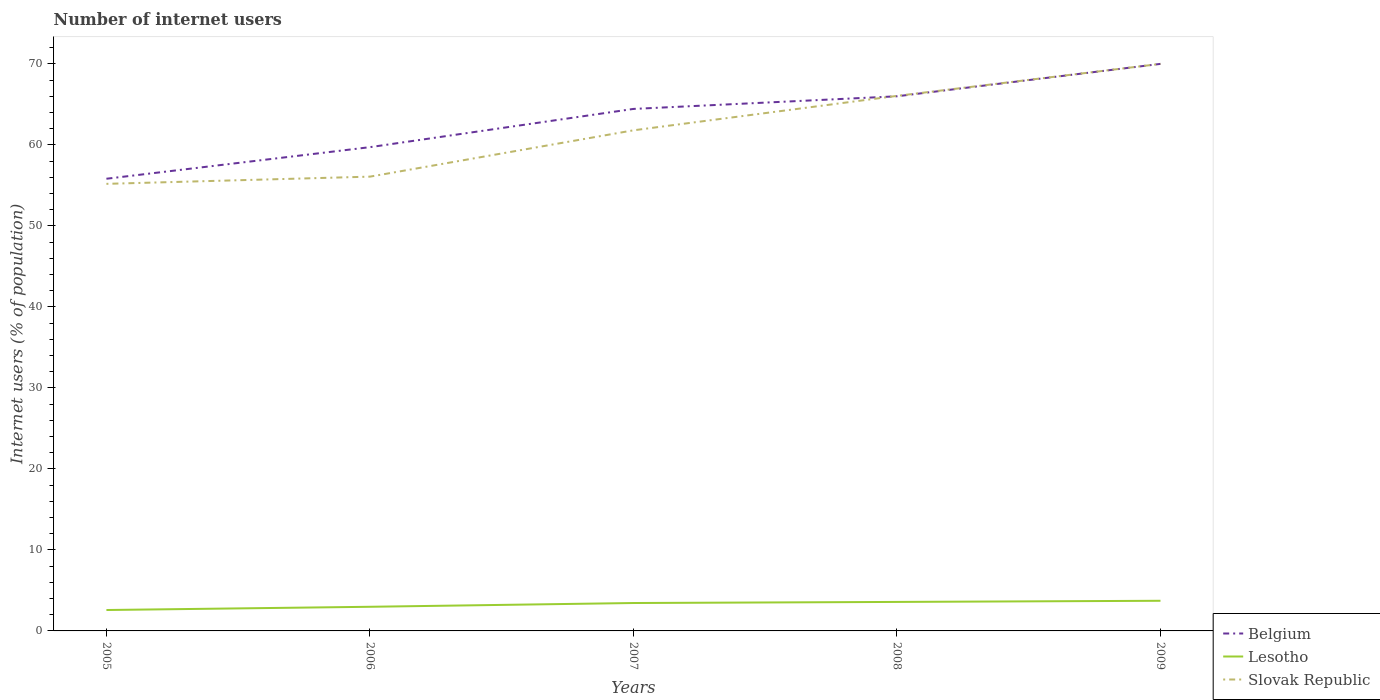How many different coloured lines are there?
Provide a succinct answer. 3. Does the line corresponding to Slovak Republic intersect with the line corresponding to Lesotho?
Provide a short and direct response. No. Is the number of lines equal to the number of legend labels?
Offer a terse response. Yes. Across all years, what is the maximum number of internet users in Lesotho?
Keep it short and to the point. 2.58. In which year was the number of internet users in Slovak Republic maximum?
Make the answer very short. 2005. What is the total number of internet users in Lesotho in the graph?
Offer a terse response. -0.87. What is the difference between the highest and the second highest number of internet users in Slovak Republic?
Your answer should be very brief. 14.81. Is the number of internet users in Belgium strictly greater than the number of internet users in Lesotho over the years?
Your answer should be compact. No. How many legend labels are there?
Your response must be concise. 3. What is the title of the graph?
Offer a terse response. Number of internet users. Does "Burundi" appear as one of the legend labels in the graph?
Ensure brevity in your answer.  No. What is the label or title of the X-axis?
Offer a terse response. Years. What is the label or title of the Y-axis?
Your response must be concise. Internet users (% of population). What is the Internet users (% of population) in Belgium in 2005?
Offer a terse response. 55.82. What is the Internet users (% of population) in Lesotho in 2005?
Your answer should be compact. 2.58. What is the Internet users (% of population) of Slovak Republic in 2005?
Give a very brief answer. 55.19. What is the Internet users (% of population) in Belgium in 2006?
Make the answer very short. 59.72. What is the Internet users (% of population) of Lesotho in 2006?
Your answer should be compact. 2.98. What is the Internet users (% of population) in Slovak Republic in 2006?
Make the answer very short. 56.08. What is the Internet users (% of population) of Belgium in 2007?
Provide a short and direct response. 64.44. What is the Internet users (% of population) in Lesotho in 2007?
Your response must be concise. 3.45. What is the Internet users (% of population) in Slovak Republic in 2007?
Provide a short and direct response. 61.8. What is the Internet users (% of population) of Belgium in 2008?
Give a very brief answer. 66. What is the Internet users (% of population) in Lesotho in 2008?
Provide a succinct answer. 3.58. What is the Internet users (% of population) of Slovak Republic in 2008?
Offer a terse response. 66.05. What is the Internet users (% of population) of Belgium in 2009?
Your answer should be very brief. 70. What is the Internet users (% of population) of Lesotho in 2009?
Offer a very short reply. 3.72. Across all years, what is the maximum Internet users (% of population) in Belgium?
Keep it short and to the point. 70. Across all years, what is the maximum Internet users (% of population) in Lesotho?
Keep it short and to the point. 3.72. Across all years, what is the maximum Internet users (% of population) in Slovak Republic?
Provide a succinct answer. 70. Across all years, what is the minimum Internet users (% of population) in Belgium?
Offer a terse response. 55.82. Across all years, what is the minimum Internet users (% of population) of Lesotho?
Provide a short and direct response. 2.58. Across all years, what is the minimum Internet users (% of population) of Slovak Republic?
Offer a very short reply. 55.19. What is the total Internet users (% of population) in Belgium in the graph?
Your answer should be very brief. 315.98. What is the total Internet users (% of population) of Lesotho in the graph?
Offer a very short reply. 16.31. What is the total Internet users (% of population) in Slovak Republic in the graph?
Give a very brief answer. 309.12. What is the difference between the Internet users (% of population) in Belgium in 2005 and that in 2006?
Provide a short and direct response. -3.9. What is the difference between the Internet users (% of population) in Lesotho in 2005 and that in 2006?
Offer a very short reply. -0.4. What is the difference between the Internet users (% of population) of Slovak Republic in 2005 and that in 2006?
Offer a very short reply. -0.89. What is the difference between the Internet users (% of population) in Belgium in 2005 and that in 2007?
Your response must be concise. -8.62. What is the difference between the Internet users (% of population) in Lesotho in 2005 and that in 2007?
Your response must be concise. -0.87. What is the difference between the Internet users (% of population) of Slovak Republic in 2005 and that in 2007?
Ensure brevity in your answer.  -6.61. What is the difference between the Internet users (% of population) in Belgium in 2005 and that in 2008?
Make the answer very short. -10.18. What is the difference between the Internet users (% of population) of Lesotho in 2005 and that in 2008?
Your response must be concise. -1. What is the difference between the Internet users (% of population) of Slovak Republic in 2005 and that in 2008?
Ensure brevity in your answer.  -10.86. What is the difference between the Internet users (% of population) of Belgium in 2005 and that in 2009?
Provide a succinct answer. -14.18. What is the difference between the Internet users (% of population) of Lesotho in 2005 and that in 2009?
Ensure brevity in your answer.  -1.14. What is the difference between the Internet users (% of population) of Slovak Republic in 2005 and that in 2009?
Your answer should be very brief. -14.81. What is the difference between the Internet users (% of population) of Belgium in 2006 and that in 2007?
Offer a terse response. -4.72. What is the difference between the Internet users (% of population) of Lesotho in 2006 and that in 2007?
Give a very brief answer. -0.47. What is the difference between the Internet users (% of population) in Slovak Republic in 2006 and that in 2007?
Keep it short and to the point. -5.72. What is the difference between the Internet users (% of population) in Belgium in 2006 and that in 2008?
Offer a very short reply. -6.28. What is the difference between the Internet users (% of population) in Lesotho in 2006 and that in 2008?
Keep it short and to the point. -0.6. What is the difference between the Internet users (% of population) in Slovak Republic in 2006 and that in 2008?
Your response must be concise. -9.97. What is the difference between the Internet users (% of population) in Belgium in 2006 and that in 2009?
Provide a succinct answer. -10.28. What is the difference between the Internet users (% of population) in Lesotho in 2006 and that in 2009?
Your answer should be compact. -0.74. What is the difference between the Internet users (% of population) in Slovak Republic in 2006 and that in 2009?
Keep it short and to the point. -13.92. What is the difference between the Internet users (% of population) in Belgium in 2007 and that in 2008?
Ensure brevity in your answer.  -1.56. What is the difference between the Internet users (% of population) in Lesotho in 2007 and that in 2008?
Offer a very short reply. -0.13. What is the difference between the Internet users (% of population) in Slovak Republic in 2007 and that in 2008?
Ensure brevity in your answer.  -4.25. What is the difference between the Internet users (% of population) in Belgium in 2007 and that in 2009?
Offer a terse response. -5.56. What is the difference between the Internet users (% of population) in Lesotho in 2007 and that in 2009?
Provide a short and direct response. -0.27. What is the difference between the Internet users (% of population) in Slovak Republic in 2007 and that in 2009?
Provide a short and direct response. -8.2. What is the difference between the Internet users (% of population) in Lesotho in 2008 and that in 2009?
Keep it short and to the point. -0.14. What is the difference between the Internet users (% of population) in Slovak Republic in 2008 and that in 2009?
Make the answer very short. -3.95. What is the difference between the Internet users (% of population) of Belgium in 2005 and the Internet users (% of population) of Lesotho in 2006?
Keep it short and to the point. 52.84. What is the difference between the Internet users (% of population) of Belgium in 2005 and the Internet users (% of population) of Slovak Republic in 2006?
Provide a succinct answer. -0.26. What is the difference between the Internet users (% of population) in Lesotho in 2005 and the Internet users (% of population) in Slovak Republic in 2006?
Keep it short and to the point. -53.5. What is the difference between the Internet users (% of population) of Belgium in 2005 and the Internet users (% of population) of Lesotho in 2007?
Keep it short and to the point. 52.37. What is the difference between the Internet users (% of population) of Belgium in 2005 and the Internet users (% of population) of Slovak Republic in 2007?
Offer a terse response. -5.98. What is the difference between the Internet users (% of population) in Lesotho in 2005 and the Internet users (% of population) in Slovak Republic in 2007?
Make the answer very short. -59.22. What is the difference between the Internet users (% of population) in Belgium in 2005 and the Internet users (% of population) in Lesotho in 2008?
Give a very brief answer. 52.24. What is the difference between the Internet users (% of population) in Belgium in 2005 and the Internet users (% of population) in Slovak Republic in 2008?
Your response must be concise. -10.23. What is the difference between the Internet users (% of population) in Lesotho in 2005 and the Internet users (% of population) in Slovak Republic in 2008?
Your response must be concise. -63.47. What is the difference between the Internet users (% of population) in Belgium in 2005 and the Internet users (% of population) in Lesotho in 2009?
Offer a terse response. 52.1. What is the difference between the Internet users (% of population) in Belgium in 2005 and the Internet users (% of population) in Slovak Republic in 2009?
Provide a short and direct response. -14.18. What is the difference between the Internet users (% of population) in Lesotho in 2005 and the Internet users (% of population) in Slovak Republic in 2009?
Provide a succinct answer. -67.42. What is the difference between the Internet users (% of population) of Belgium in 2006 and the Internet users (% of population) of Lesotho in 2007?
Keep it short and to the point. 56.27. What is the difference between the Internet users (% of population) of Belgium in 2006 and the Internet users (% of population) of Slovak Republic in 2007?
Offer a very short reply. -2.08. What is the difference between the Internet users (% of population) in Lesotho in 2006 and the Internet users (% of population) in Slovak Republic in 2007?
Ensure brevity in your answer.  -58.82. What is the difference between the Internet users (% of population) in Belgium in 2006 and the Internet users (% of population) in Lesotho in 2008?
Your answer should be very brief. 56.14. What is the difference between the Internet users (% of population) of Belgium in 2006 and the Internet users (% of population) of Slovak Republic in 2008?
Your answer should be compact. -6.33. What is the difference between the Internet users (% of population) of Lesotho in 2006 and the Internet users (% of population) of Slovak Republic in 2008?
Your answer should be compact. -63.07. What is the difference between the Internet users (% of population) in Belgium in 2006 and the Internet users (% of population) in Lesotho in 2009?
Provide a succinct answer. 56. What is the difference between the Internet users (% of population) in Belgium in 2006 and the Internet users (% of population) in Slovak Republic in 2009?
Your answer should be compact. -10.28. What is the difference between the Internet users (% of population) in Lesotho in 2006 and the Internet users (% of population) in Slovak Republic in 2009?
Your answer should be compact. -67.02. What is the difference between the Internet users (% of population) in Belgium in 2007 and the Internet users (% of population) in Lesotho in 2008?
Provide a succinct answer. 60.86. What is the difference between the Internet users (% of population) in Belgium in 2007 and the Internet users (% of population) in Slovak Republic in 2008?
Provide a short and direct response. -1.61. What is the difference between the Internet users (% of population) of Lesotho in 2007 and the Internet users (% of population) of Slovak Republic in 2008?
Provide a succinct answer. -62.6. What is the difference between the Internet users (% of population) of Belgium in 2007 and the Internet users (% of population) of Lesotho in 2009?
Make the answer very short. 60.72. What is the difference between the Internet users (% of population) in Belgium in 2007 and the Internet users (% of population) in Slovak Republic in 2009?
Give a very brief answer. -5.56. What is the difference between the Internet users (% of population) in Lesotho in 2007 and the Internet users (% of population) in Slovak Republic in 2009?
Provide a succinct answer. -66.55. What is the difference between the Internet users (% of population) of Belgium in 2008 and the Internet users (% of population) of Lesotho in 2009?
Provide a succinct answer. 62.28. What is the difference between the Internet users (% of population) in Lesotho in 2008 and the Internet users (% of population) in Slovak Republic in 2009?
Ensure brevity in your answer.  -66.42. What is the average Internet users (% of population) of Belgium per year?
Make the answer very short. 63.2. What is the average Internet users (% of population) of Lesotho per year?
Provide a short and direct response. 3.26. What is the average Internet users (% of population) of Slovak Republic per year?
Provide a short and direct response. 61.82. In the year 2005, what is the difference between the Internet users (% of population) of Belgium and Internet users (% of population) of Lesotho?
Provide a succinct answer. 53.24. In the year 2005, what is the difference between the Internet users (% of population) in Belgium and Internet users (% of population) in Slovak Republic?
Offer a terse response. 0.63. In the year 2005, what is the difference between the Internet users (% of population) of Lesotho and Internet users (% of population) of Slovak Republic?
Offer a very short reply. -52.61. In the year 2006, what is the difference between the Internet users (% of population) of Belgium and Internet users (% of population) of Lesotho?
Provide a short and direct response. 56.74. In the year 2006, what is the difference between the Internet users (% of population) of Belgium and Internet users (% of population) of Slovak Republic?
Your response must be concise. 3.64. In the year 2006, what is the difference between the Internet users (% of population) in Lesotho and Internet users (% of population) in Slovak Republic?
Ensure brevity in your answer.  -53.1. In the year 2007, what is the difference between the Internet users (% of population) of Belgium and Internet users (% of population) of Lesotho?
Your answer should be compact. 60.99. In the year 2007, what is the difference between the Internet users (% of population) of Belgium and Internet users (% of population) of Slovak Republic?
Give a very brief answer. 2.64. In the year 2007, what is the difference between the Internet users (% of population) in Lesotho and Internet users (% of population) in Slovak Republic?
Make the answer very short. -58.35. In the year 2008, what is the difference between the Internet users (% of population) of Belgium and Internet users (% of population) of Lesotho?
Offer a terse response. 62.42. In the year 2008, what is the difference between the Internet users (% of population) in Belgium and Internet users (% of population) in Slovak Republic?
Make the answer very short. -0.05. In the year 2008, what is the difference between the Internet users (% of population) of Lesotho and Internet users (% of population) of Slovak Republic?
Offer a very short reply. -62.47. In the year 2009, what is the difference between the Internet users (% of population) of Belgium and Internet users (% of population) of Lesotho?
Provide a succinct answer. 66.28. In the year 2009, what is the difference between the Internet users (% of population) in Belgium and Internet users (% of population) in Slovak Republic?
Keep it short and to the point. 0. In the year 2009, what is the difference between the Internet users (% of population) in Lesotho and Internet users (% of population) in Slovak Republic?
Give a very brief answer. -66.28. What is the ratio of the Internet users (% of population) in Belgium in 2005 to that in 2006?
Offer a terse response. 0.93. What is the ratio of the Internet users (% of population) of Lesotho in 2005 to that in 2006?
Your response must be concise. 0.87. What is the ratio of the Internet users (% of population) of Slovak Republic in 2005 to that in 2006?
Give a very brief answer. 0.98. What is the ratio of the Internet users (% of population) in Belgium in 2005 to that in 2007?
Keep it short and to the point. 0.87. What is the ratio of the Internet users (% of population) in Lesotho in 2005 to that in 2007?
Your response must be concise. 0.75. What is the ratio of the Internet users (% of population) in Slovak Republic in 2005 to that in 2007?
Give a very brief answer. 0.89. What is the ratio of the Internet users (% of population) of Belgium in 2005 to that in 2008?
Your response must be concise. 0.85. What is the ratio of the Internet users (% of population) in Lesotho in 2005 to that in 2008?
Ensure brevity in your answer.  0.72. What is the ratio of the Internet users (% of population) of Slovak Republic in 2005 to that in 2008?
Provide a succinct answer. 0.84. What is the ratio of the Internet users (% of population) in Belgium in 2005 to that in 2009?
Your response must be concise. 0.8. What is the ratio of the Internet users (% of population) of Lesotho in 2005 to that in 2009?
Provide a short and direct response. 0.69. What is the ratio of the Internet users (% of population) of Slovak Republic in 2005 to that in 2009?
Give a very brief answer. 0.79. What is the ratio of the Internet users (% of population) of Belgium in 2006 to that in 2007?
Offer a very short reply. 0.93. What is the ratio of the Internet users (% of population) in Lesotho in 2006 to that in 2007?
Give a very brief answer. 0.86. What is the ratio of the Internet users (% of population) of Slovak Republic in 2006 to that in 2007?
Offer a very short reply. 0.91. What is the ratio of the Internet users (% of population) in Belgium in 2006 to that in 2008?
Provide a succinct answer. 0.9. What is the ratio of the Internet users (% of population) of Lesotho in 2006 to that in 2008?
Ensure brevity in your answer.  0.83. What is the ratio of the Internet users (% of population) of Slovak Republic in 2006 to that in 2008?
Your response must be concise. 0.85. What is the ratio of the Internet users (% of population) of Belgium in 2006 to that in 2009?
Ensure brevity in your answer.  0.85. What is the ratio of the Internet users (% of population) in Lesotho in 2006 to that in 2009?
Make the answer very short. 0.8. What is the ratio of the Internet users (% of population) of Slovak Republic in 2006 to that in 2009?
Your answer should be compact. 0.8. What is the ratio of the Internet users (% of population) in Belgium in 2007 to that in 2008?
Provide a short and direct response. 0.98. What is the ratio of the Internet users (% of population) in Lesotho in 2007 to that in 2008?
Your response must be concise. 0.96. What is the ratio of the Internet users (% of population) of Slovak Republic in 2007 to that in 2008?
Ensure brevity in your answer.  0.94. What is the ratio of the Internet users (% of population) in Belgium in 2007 to that in 2009?
Offer a very short reply. 0.92. What is the ratio of the Internet users (% of population) of Lesotho in 2007 to that in 2009?
Your response must be concise. 0.93. What is the ratio of the Internet users (% of population) in Slovak Republic in 2007 to that in 2009?
Make the answer very short. 0.88. What is the ratio of the Internet users (% of population) of Belgium in 2008 to that in 2009?
Your answer should be compact. 0.94. What is the ratio of the Internet users (% of population) of Lesotho in 2008 to that in 2009?
Your answer should be very brief. 0.96. What is the ratio of the Internet users (% of population) in Slovak Republic in 2008 to that in 2009?
Provide a succinct answer. 0.94. What is the difference between the highest and the second highest Internet users (% of population) in Lesotho?
Offer a terse response. 0.14. What is the difference between the highest and the second highest Internet users (% of population) of Slovak Republic?
Ensure brevity in your answer.  3.95. What is the difference between the highest and the lowest Internet users (% of population) in Belgium?
Your answer should be very brief. 14.18. What is the difference between the highest and the lowest Internet users (% of population) of Lesotho?
Keep it short and to the point. 1.14. What is the difference between the highest and the lowest Internet users (% of population) in Slovak Republic?
Make the answer very short. 14.81. 